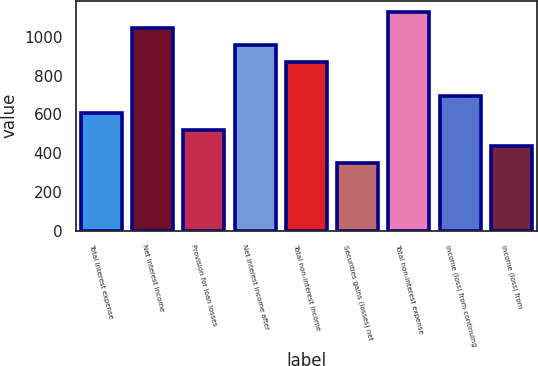<chart> <loc_0><loc_0><loc_500><loc_500><bar_chart><fcel>Total interest expense<fcel>Net interest income<fcel>Provision for loan losses<fcel>Net interest income after<fcel>Total non-interest income<fcel>Securities gains (losses) net<fcel>Total non-interest expense<fcel>Income (loss) from continuing<fcel>Income (loss) from<nl><fcel>608.31<fcel>1042.81<fcel>521.41<fcel>955.91<fcel>869.01<fcel>347.61<fcel>1129.71<fcel>695.21<fcel>434.51<nl></chart> 